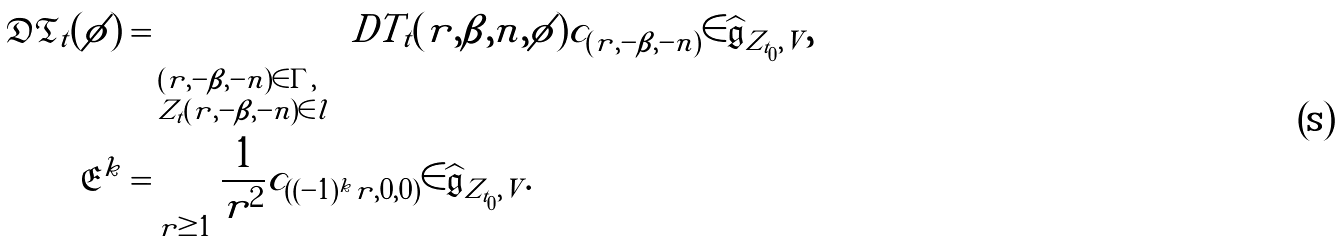<formula> <loc_0><loc_0><loc_500><loc_500>\mathfrak { D T } _ { t } ( \phi ) & = \sum _ { \begin{subarray} { c } ( r , - \beta , - n ) \in \Gamma , \\ Z _ { t } ( r , - \beta , - n ) \in l \end{subarray} } \ D T _ { t } ( r , \beta , n , \phi ) c _ { ( r , - \beta , - n ) } \in \widehat { \mathfrak { g } } _ { Z _ { t _ { 0 } } , V } , \\ \mathfrak { E } ^ { k } & = \sum _ { r \geq 1 } \frac { 1 } { r ^ { 2 } } c _ { ( ( - 1 ) ^ { k } r , 0 , 0 ) } \in \widehat { \mathfrak { g } } _ { Z _ { t _ { 0 } } , V } .</formula> 